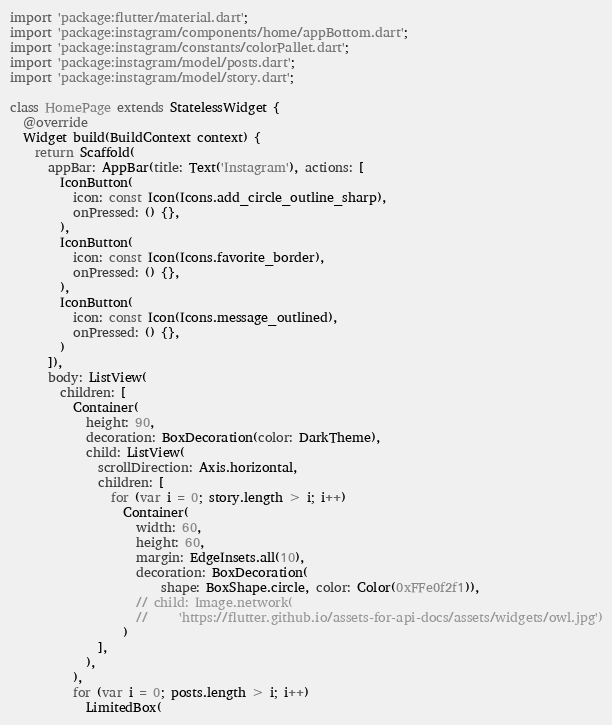<code> <loc_0><loc_0><loc_500><loc_500><_Dart_>import 'package:flutter/material.dart';
import 'package:instagram/components/home/appBottom.dart';
import 'package:instagram/constants/colorPallet.dart';
import 'package:instagram/model/posts.dart';
import 'package:instagram/model/story.dart';

class HomePage extends StatelessWidget {
  @override
  Widget build(BuildContext context) {
    return Scaffold(
      appBar: AppBar(title: Text('Instagram'), actions: [
        IconButton(
          icon: const Icon(Icons.add_circle_outline_sharp),
          onPressed: () {},
        ),
        IconButton(
          icon: const Icon(Icons.favorite_border),
          onPressed: () {},
        ),
        IconButton(
          icon: const Icon(Icons.message_outlined),
          onPressed: () {},
        )
      ]),
      body: ListView(
        children: [
          Container(
            height: 90,
            decoration: BoxDecoration(color: DarkTheme),
            child: ListView(
              scrollDirection: Axis.horizontal,
              children: [
                for (var i = 0; story.length > i; i++)
                  Container(
                    width: 60,
                    height: 60,
                    margin: EdgeInsets.all(10),
                    decoration: BoxDecoration(
                        shape: BoxShape.circle, color: Color(0xFFe0f2f1)),
                    // child: Image.network(
                    //     'https://flutter.github.io/assets-for-api-docs/assets/widgets/owl.jpg')
                  )
              ],
            ),
          ),
          for (var i = 0; posts.length > i; i++)
            LimitedBox(</code> 